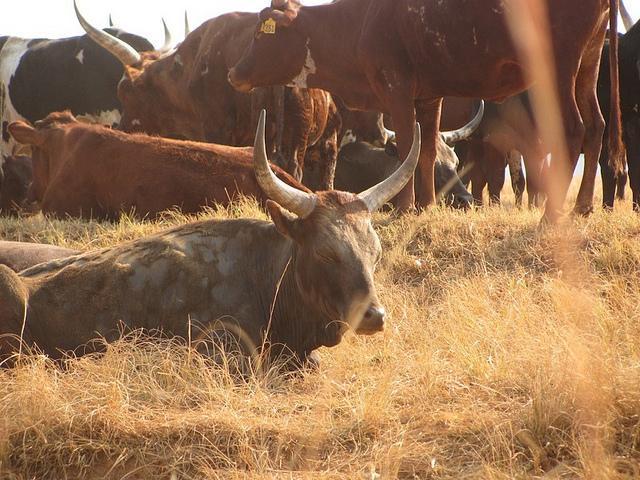How many cows are there?
Give a very brief answer. 7. How many floors does the bus have?
Give a very brief answer. 0. 